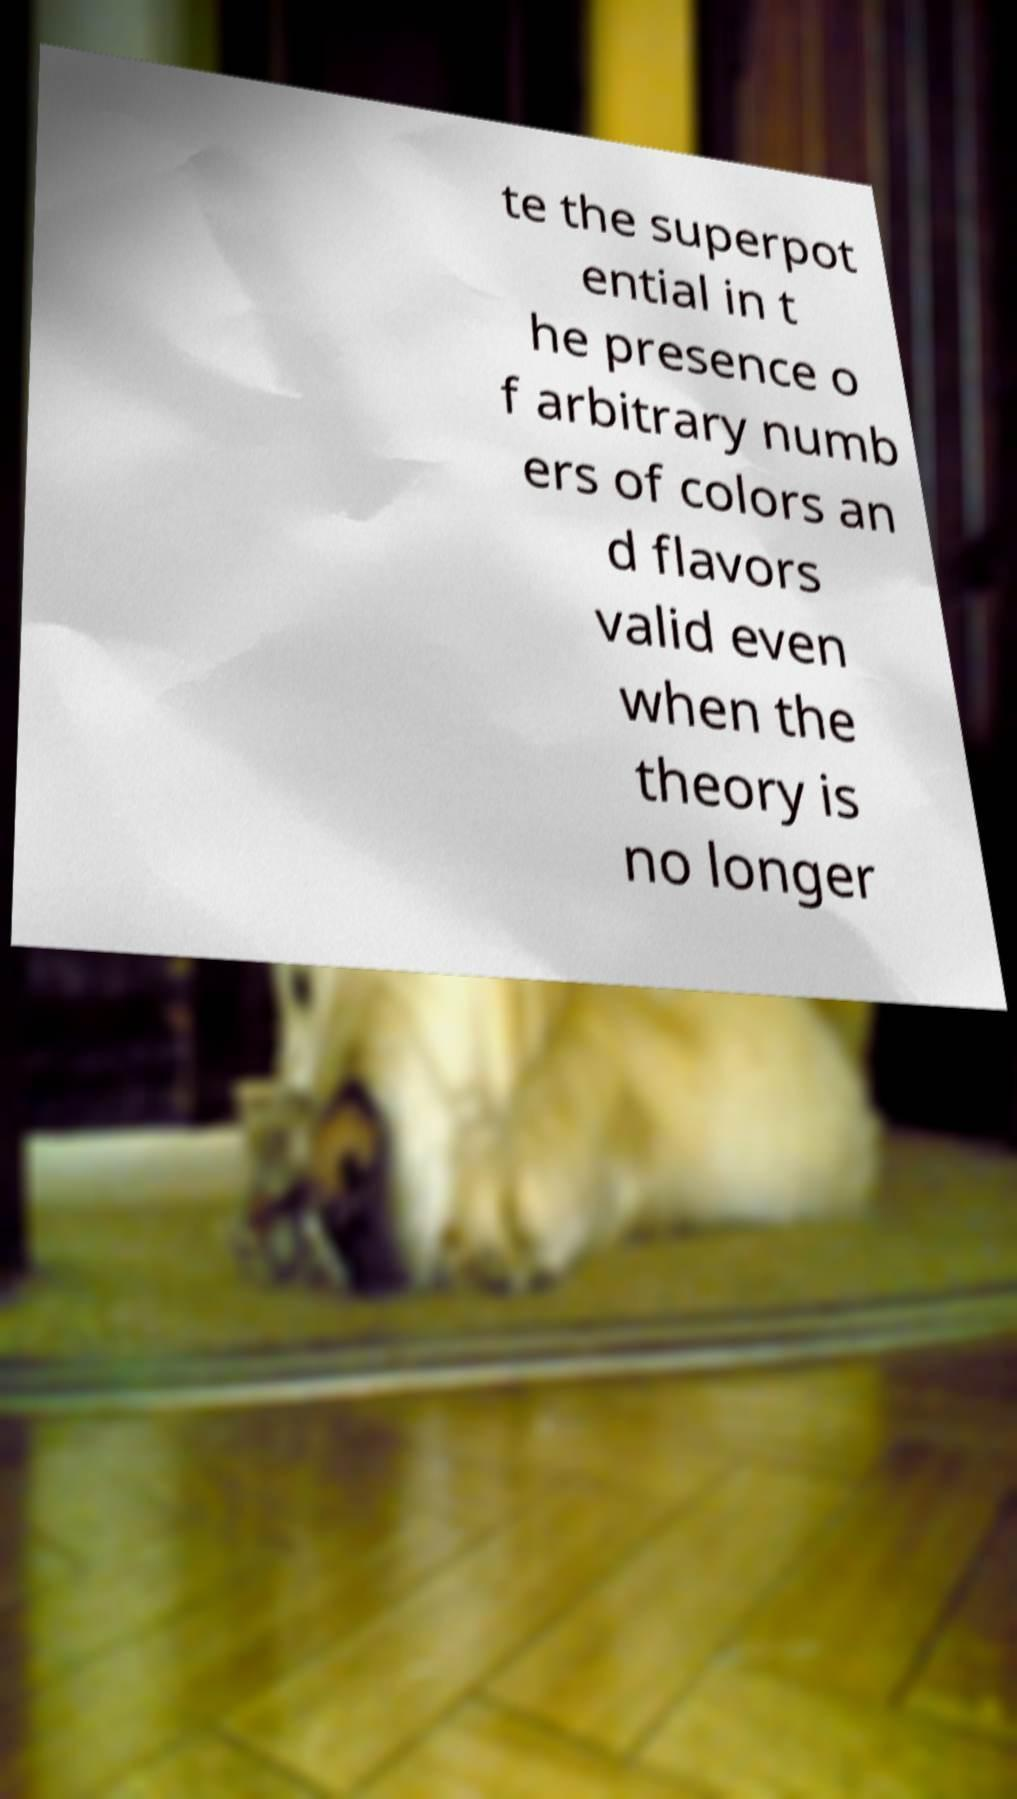I need the written content from this picture converted into text. Can you do that? te the superpot ential in t he presence o f arbitrary numb ers of colors an d flavors valid even when the theory is no longer 